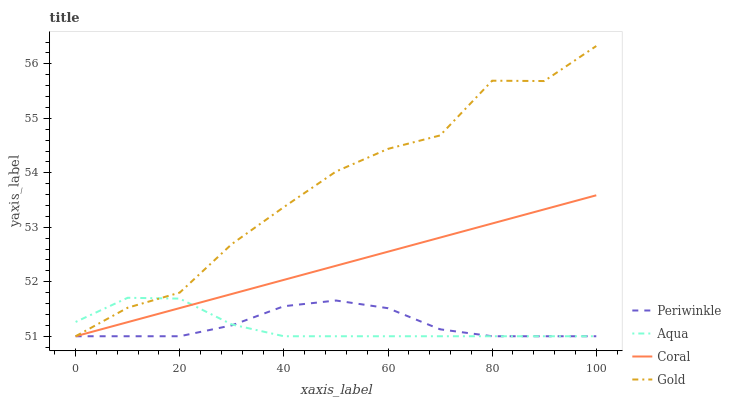Does Aqua have the minimum area under the curve?
Answer yes or no. Yes. Does Gold have the maximum area under the curve?
Answer yes or no. Yes. Does Coral have the minimum area under the curve?
Answer yes or no. No. Does Coral have the maximum area under the curve?
Answer yes or no. No. Is Coral the smoothest?
Answer yes or no. Yes. Is Gold the roughest?
Answer yes or no. Yes. Is Periwinkle the smoothest?
Answer yes or no. No. Is Periwinkle the roughest?
Answer yes or no. No. Does Aqua have the lowest value?
Answer yes or no. Yes. Does Gold have the highest value?
Answer yes or no. Yes. Does Coral have the highest value?
Answer yes or no. No. Does Aqua intersect Coral?
Answer yes or no. Yes. Is Aqua less than Coral?
Answer yes or no. No. Is Aqua greater than Coral?
Answer yes or no. No. 